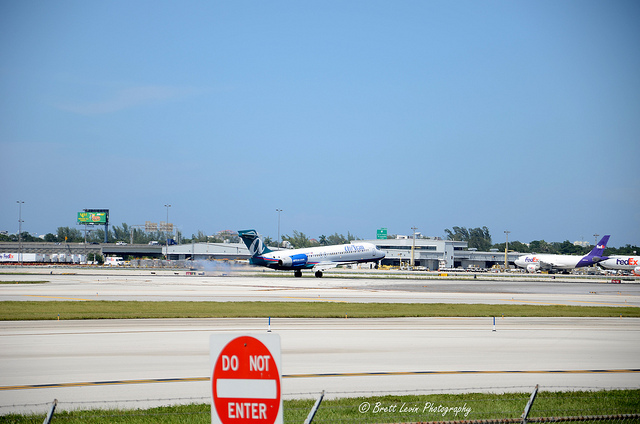What does the sign in front of the runways near the camera say? The sign in the image situated near the runways and in clear view of the camera displays the message 'DO NOT ENTER'. This is a standard traffic sign often used to indicate a road or path where vehicles are not allowed to enter. 